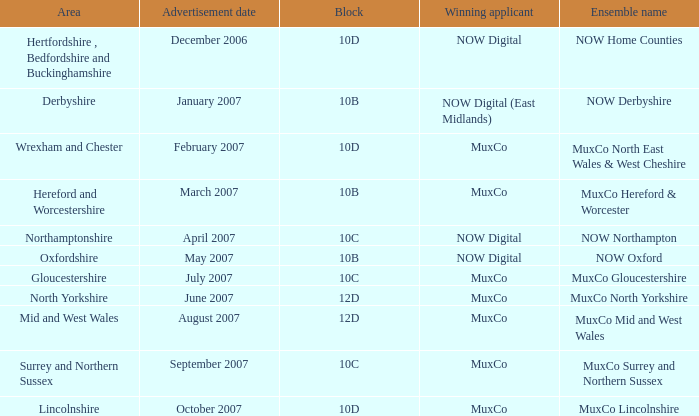Which Ensemble Name has the Advertisement date October 2007? MuxCo Lincolnshire. 